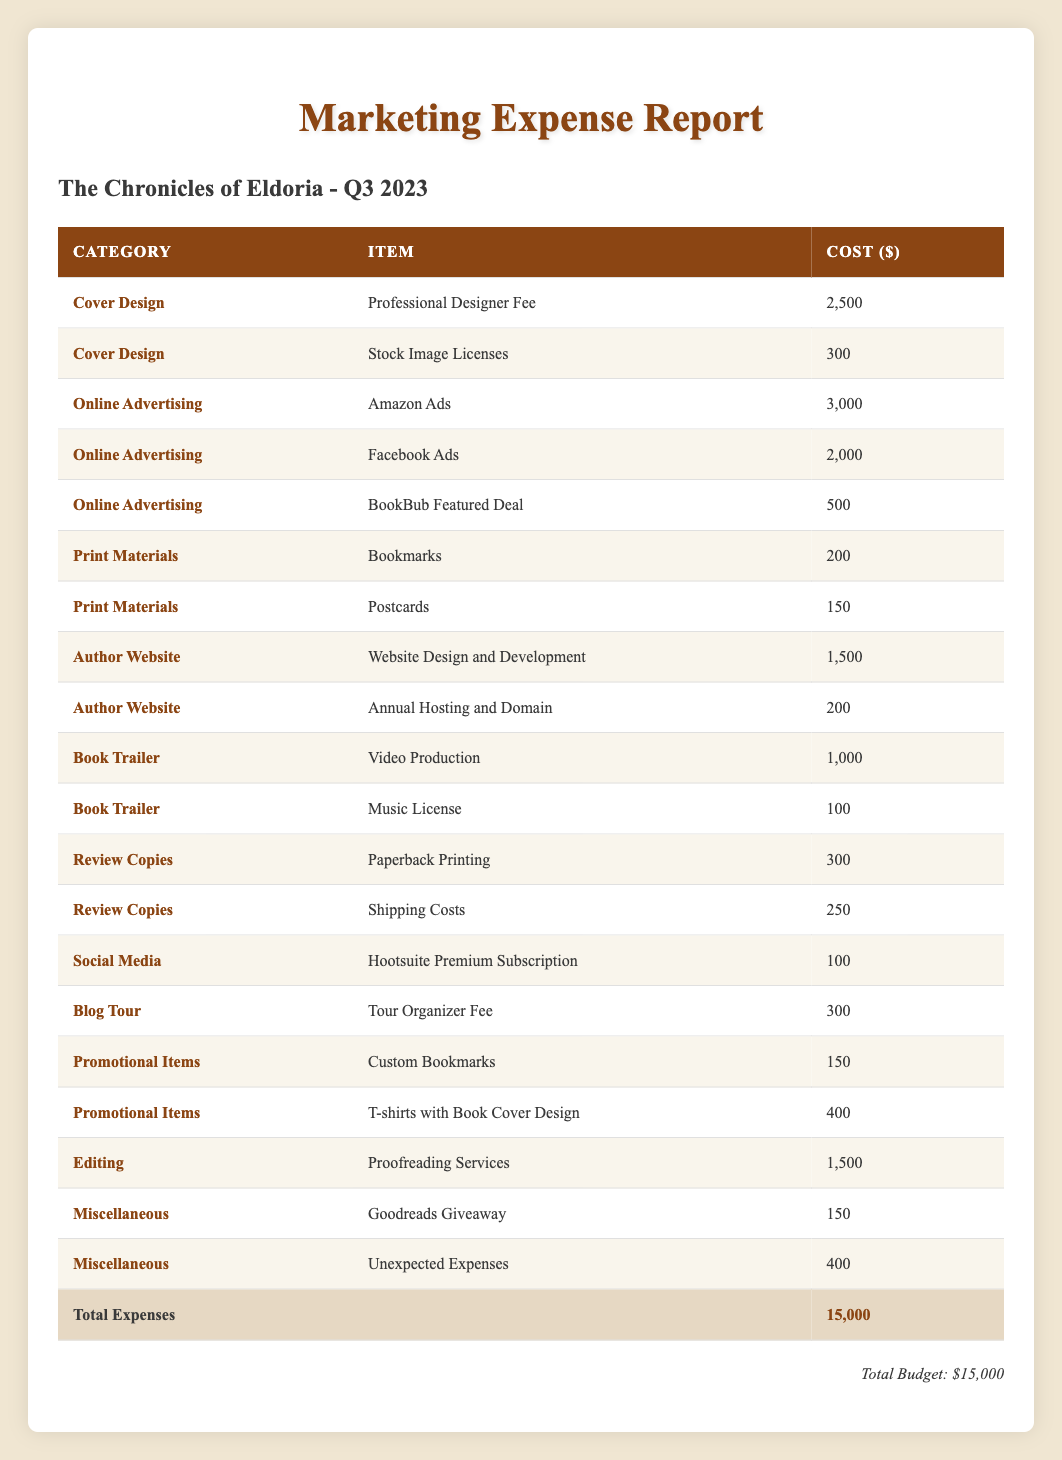What is the total cost of online advertising? The total cost of online advertising can be calculated by adding all individual online advertising costs listed in the table: Amazon Ads (3000) + Facebook Ads (2000) + BookBub Featured Deal (500) = 3000 + 2000 + 500 = 5500.
Answer: 5500 Which category has the highest single expense? By examining each category and their associated items, the highest single expense is the Professional Designer Fee under the Cover Design category, with a cost of 2500.
Answer: 2500 Is the total marketing expense equal to the budget allocated? To determine if the total marketing expense equals the budget, we check the total expenses listed (15000) against the budget stated at the bottom of the table (15000). Since both values match, the statement is true.
Answer: Yes How much was spent on print materials in total? The total spent on print materials is calculated by adding the costs for the items in the Print Materials category: Bookmarks (200) + Postcards (150) = 200 + 150 = 350.
Answer: 350 What percentage of the total budget was spent on editing services? The cost of editing services is 1500, and the total budget is 15000. To find the percentage, we use the formula: (1500 / 15000) × 100 = 10%. Therefore, 10% of the total budget was spent on editing services.
Answer: 10% What was the total cost for promotional items? The total cost for promotional items includes costs for Custom Bookmarks (150) and T-shirts with Book Cover Design (400). Summing them gives us 150 + 400 = 550.
Answer: 550 Were any review copy expenses listed? Yes, there are expenses listed under the Review Copies category, which includes Paperback Printing (300) and Shipping Costs (250), indicating that costs were incurred for review copies.
Answer: Yes What is the combined cost of all items under miscellaneous expenses? The combined cost of miscellaneous expenses can be calculated by adding the items under the Miscellaneous category: Goodreads Giveaway (150) + Unexpected Expenses (400) = 150 + 400 = 550.
Answer: 550 How does the total cost of the author website compare to the total cost of cover design? The total cost of the author website is 1700 (Website Design and Development 1500 + Annual Hosting and Domain 200), while the total cover design cost is 2800 (Professional Designer Fee 2500 + Stock Image Licenses 300). Since 1700 is less than 2800, the author website cost is lower.
Answer: Lower 